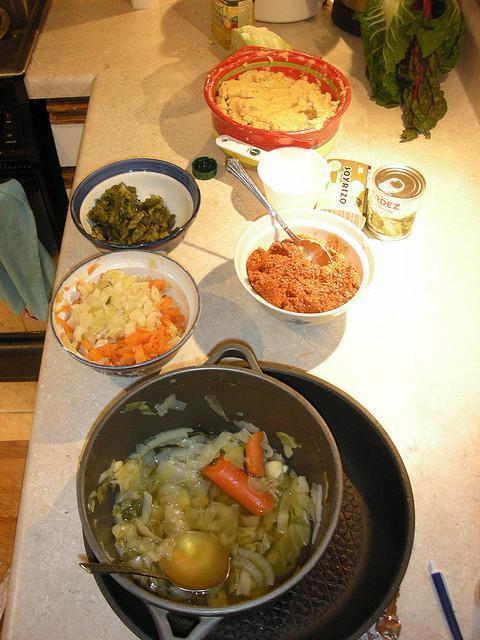How many bowls are in this picture?
Give a very brief answer. 4. How many bowls are in the photo?
Give a very brief answer. 5. How many spoons can be seen?
Give a very brief answer. 1. How many people are posing for a photo?
Give a very brief answer. 0. 